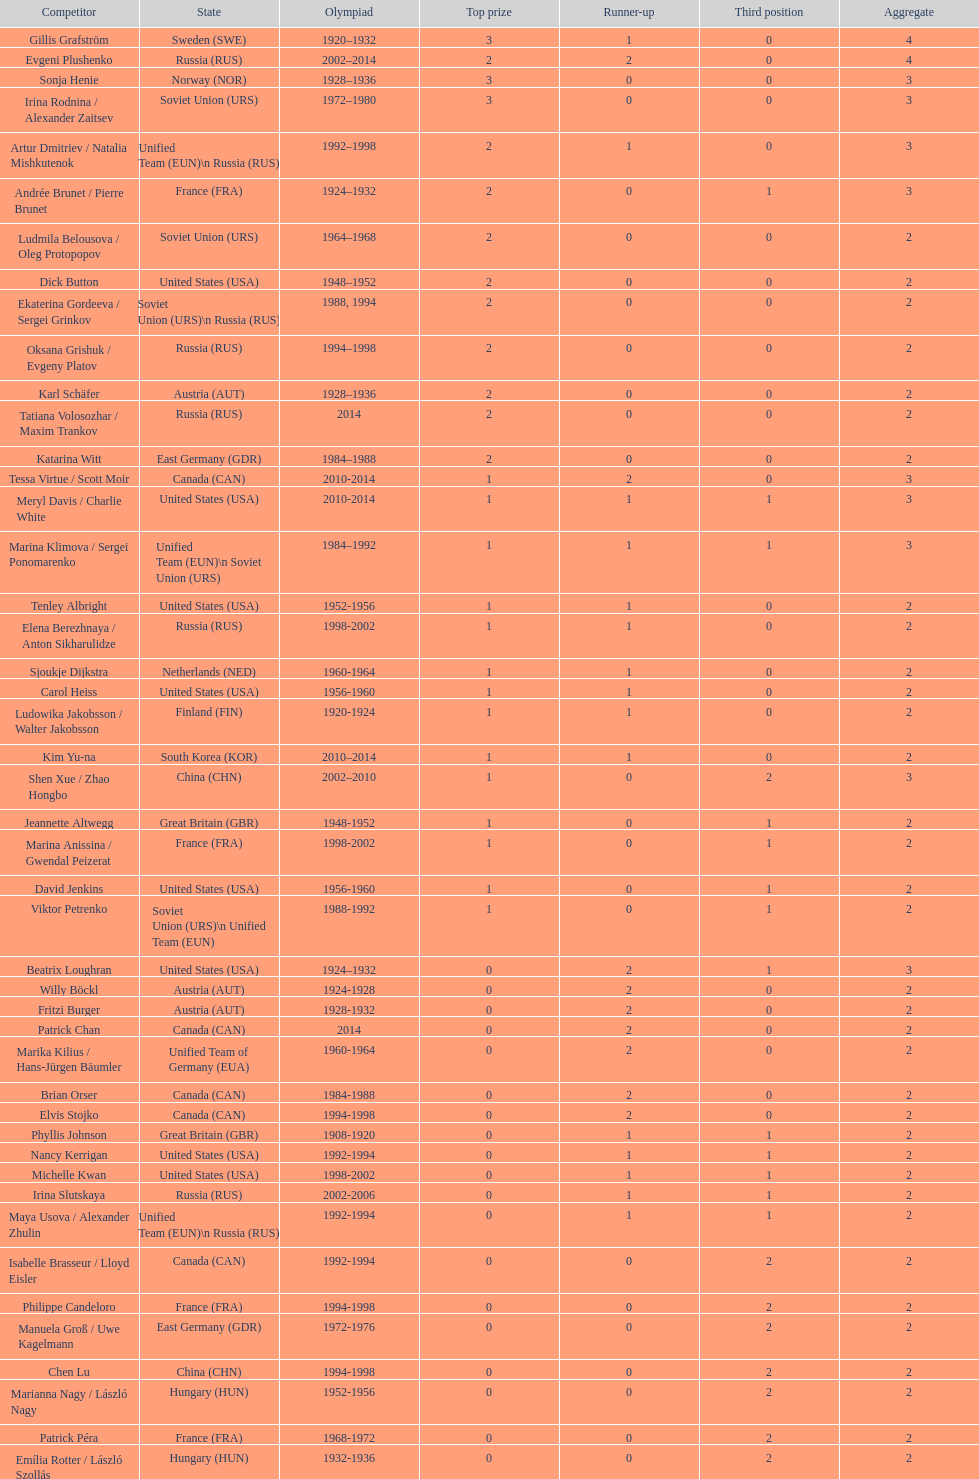Which athlete was from south korea after the year 2010? Kim Yu-na. 